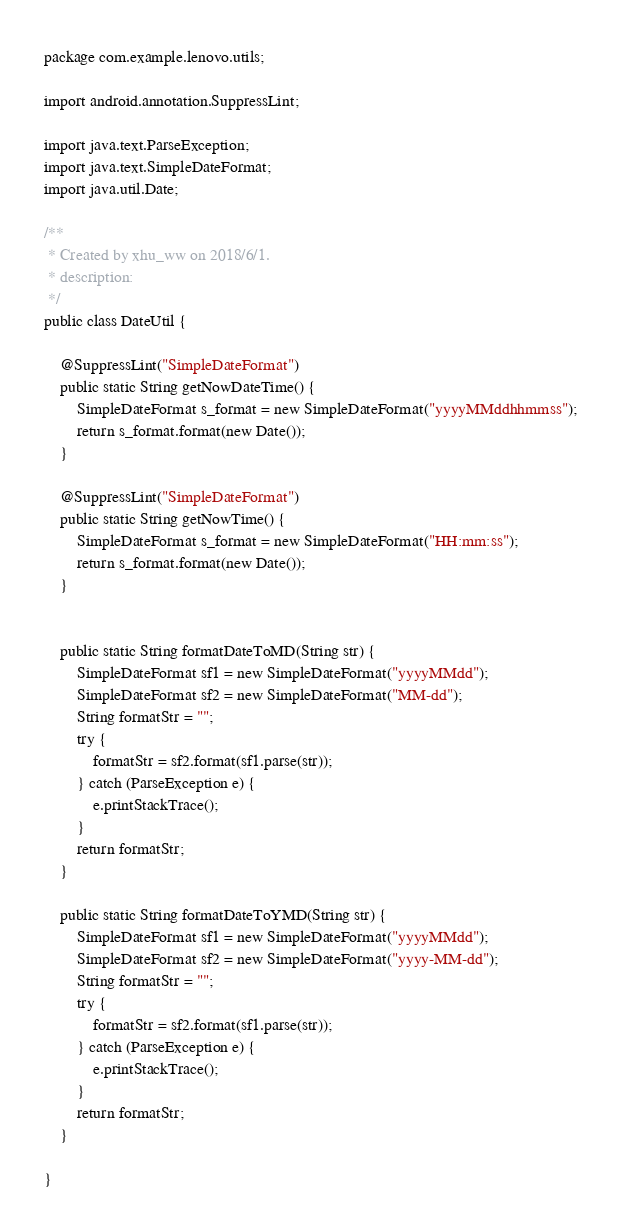Convert code to text. <code><loc_0><loc_0><loc_500><loc_500><_Java_>package com.example.lenovo.utils;

import android.annotation.SuppressLint;

import java.text.ParseException;
import java.text.SimpleDateFormat;
import java.util.Date;

/**
 * Created by xhu_ww on 2018/6/1.
 * description:
 */
public class DateUtil {

    @SuppressLint("SimpleDateFormat")
    public static String getNowDateTime() {
        SimpleDateFormat s_format = new SimpleDateFormat("yyyyMMddhhmmss");
        return s_format.format(new Date());
    }

    @SuppressLint("SimpleDateFormat")
    public static String getNowTime() {
        SimpleDateFormat s_format = new SimpleDateFormat("HH:mm:ss");
        return s_format.format(new Date());
    }


    public static String formatDateToMD(String str) {
        SimpleDateFormat sf1 = new SimpleDateFormat("yyyyMMdd");
        SimpleDateFormat sf2 = new SimpleDateFormat("MM-dd");
        String formatStr = "";
        try {
            formatStr = sf2.format(sf1.parse(str));
        } catch (ParseException e) {
            e.printStackTrace();
        }
        return formatStr;
    }

    public static String formatDateToYMD(String str) {
        SimpleDateFormat sf1 = new SimpleDateFormat("yyyyMMdd");
        SimpleDateFormat sf2 = new SimpleDateFormat("yyyy-MM-dd");
        String formatStr = "";
        try {
            formatStr = sf2.format(sf1.parse(str));
        } catch (ParseException e) {
            e.printStackTrace();
        }
        return formatStr;
    }

}
</code> 